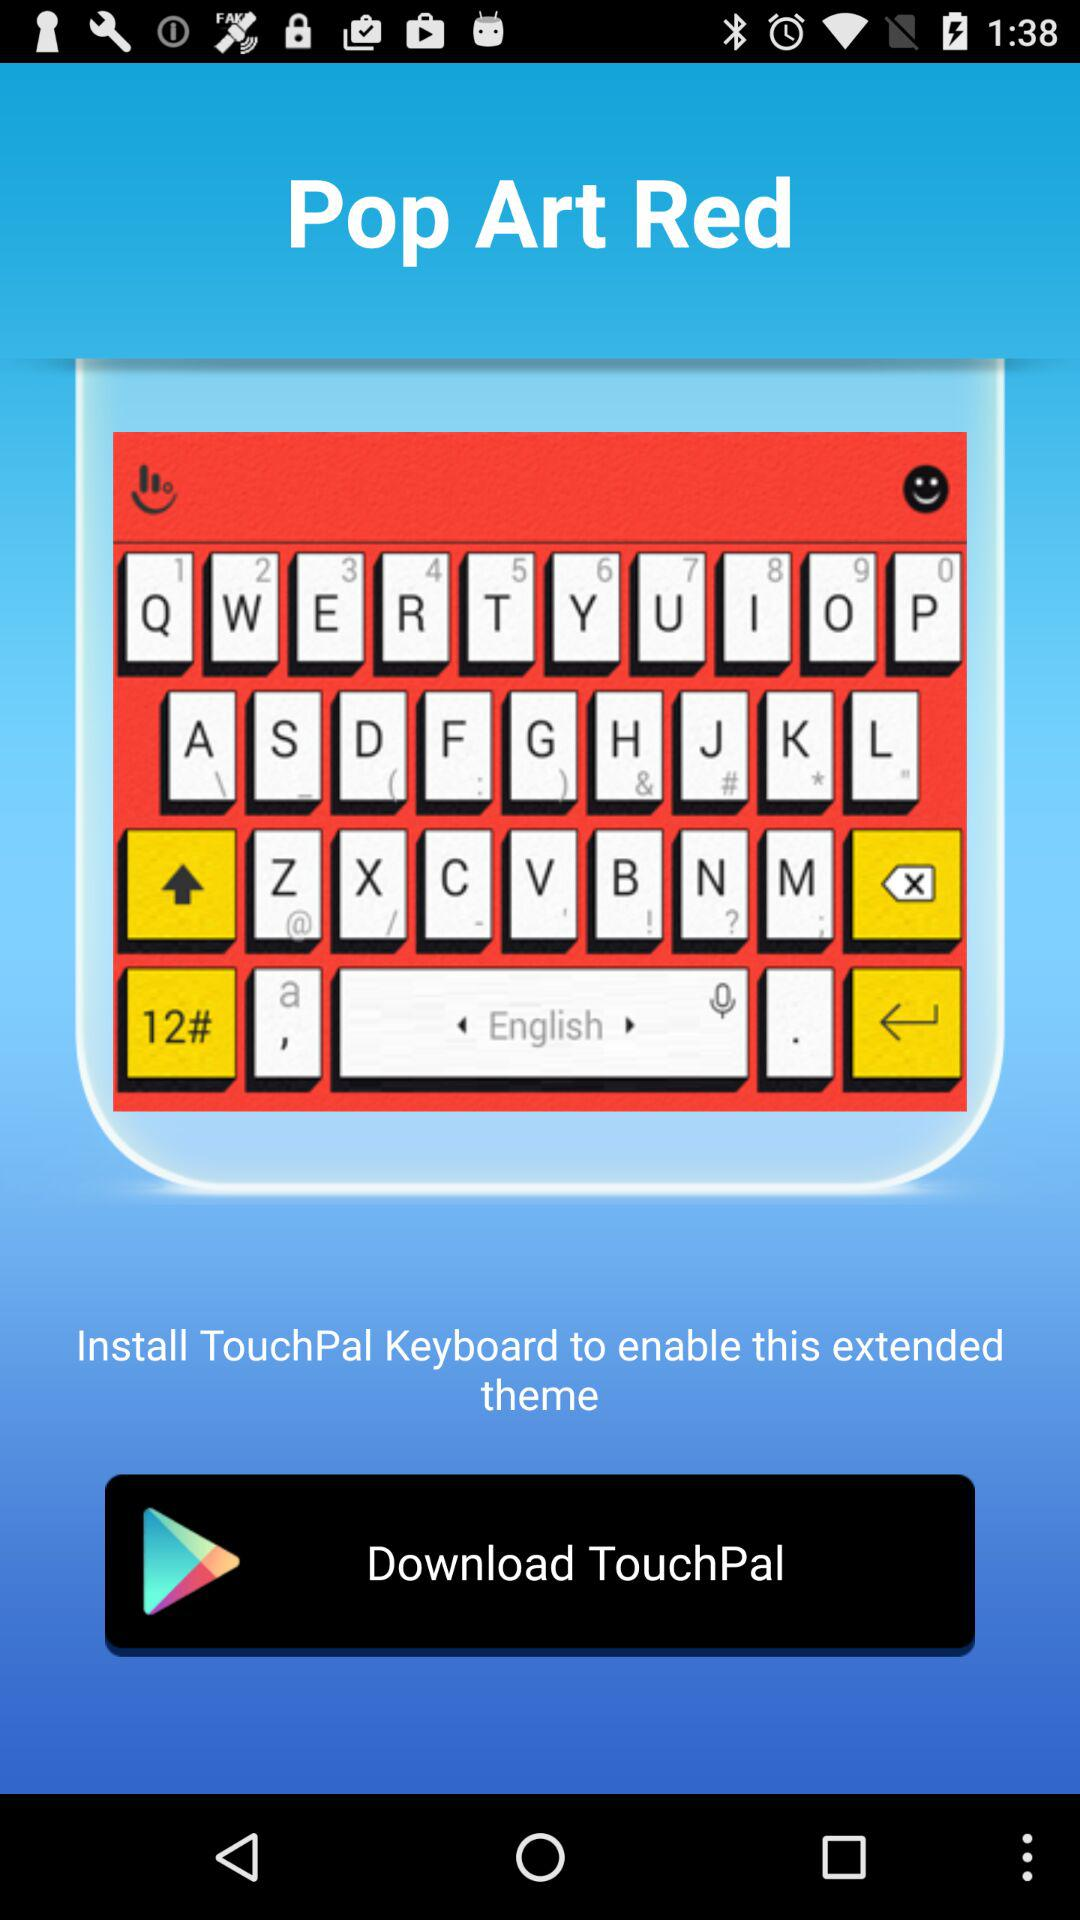To enable the extended theme, which keyboard should I install? You should install "TouchPal Keyboard". 